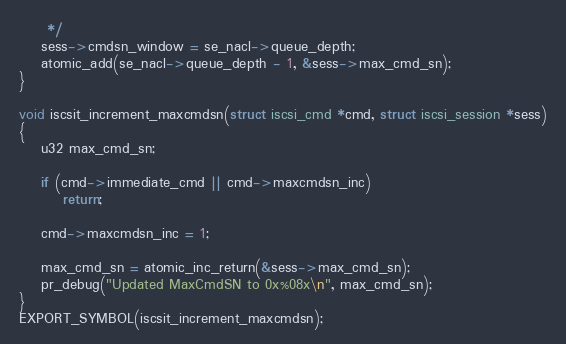Convert code to text. <code><loc_0><loc_0><loc_500><loc_500><_C_>	 */
	sess->cmdsn_window = se_nacl->queue_depth;
	atomic_add(se_nacl->queue_depth - 1, &sess->max_cmd_sn);
}

void iscsit_increment_maxcmdsn(struct iscsi_cmd *cmd, struct iscsi_session *sess)
{
	u32 max_cmd_sn;

	if (cmd->immediate_cmd || cmd->maxcmdsn_inc)
		return;

	cmd->maxcmdsn_inc = 1;

	max_cmd_sn = atomic_inc_return(&sess->max_cmd_sn);
	pr_debug("Updated MaxCmdSN to 0x%08x\n", max_cmd_sn);
}
EXPORT_SYMBOL(iscsit_increment_maxcmdsn);
</code> 